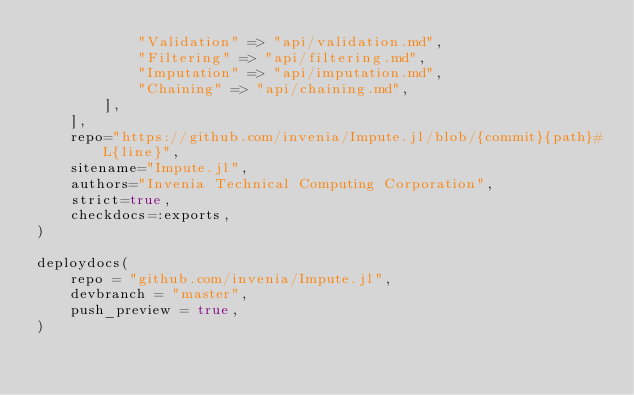<code> <loc_0><loc_0><loc_500><loc_500><_Julia_>            "Validation" => "api/validation.md",
            "Filtering" => "api/filtering.md",
            "Imputation" => "api/imputation.md",
            "Chaining" => "api/chaining.md",
        ],
    ],
    repo="https://github.com/invenia/Impute.jl/blob/{commit}{path}#L{line}",
    sitename="Impute.jl",
    authors="Invenia Technical Computing Corporation",
    strict=true,
    checkdocs=:exports,
)

deploydocs(
    repo = "github.com/invenia/Impute.jl",
    devbranch = "master",
    push_preview = true,
)
</code> 